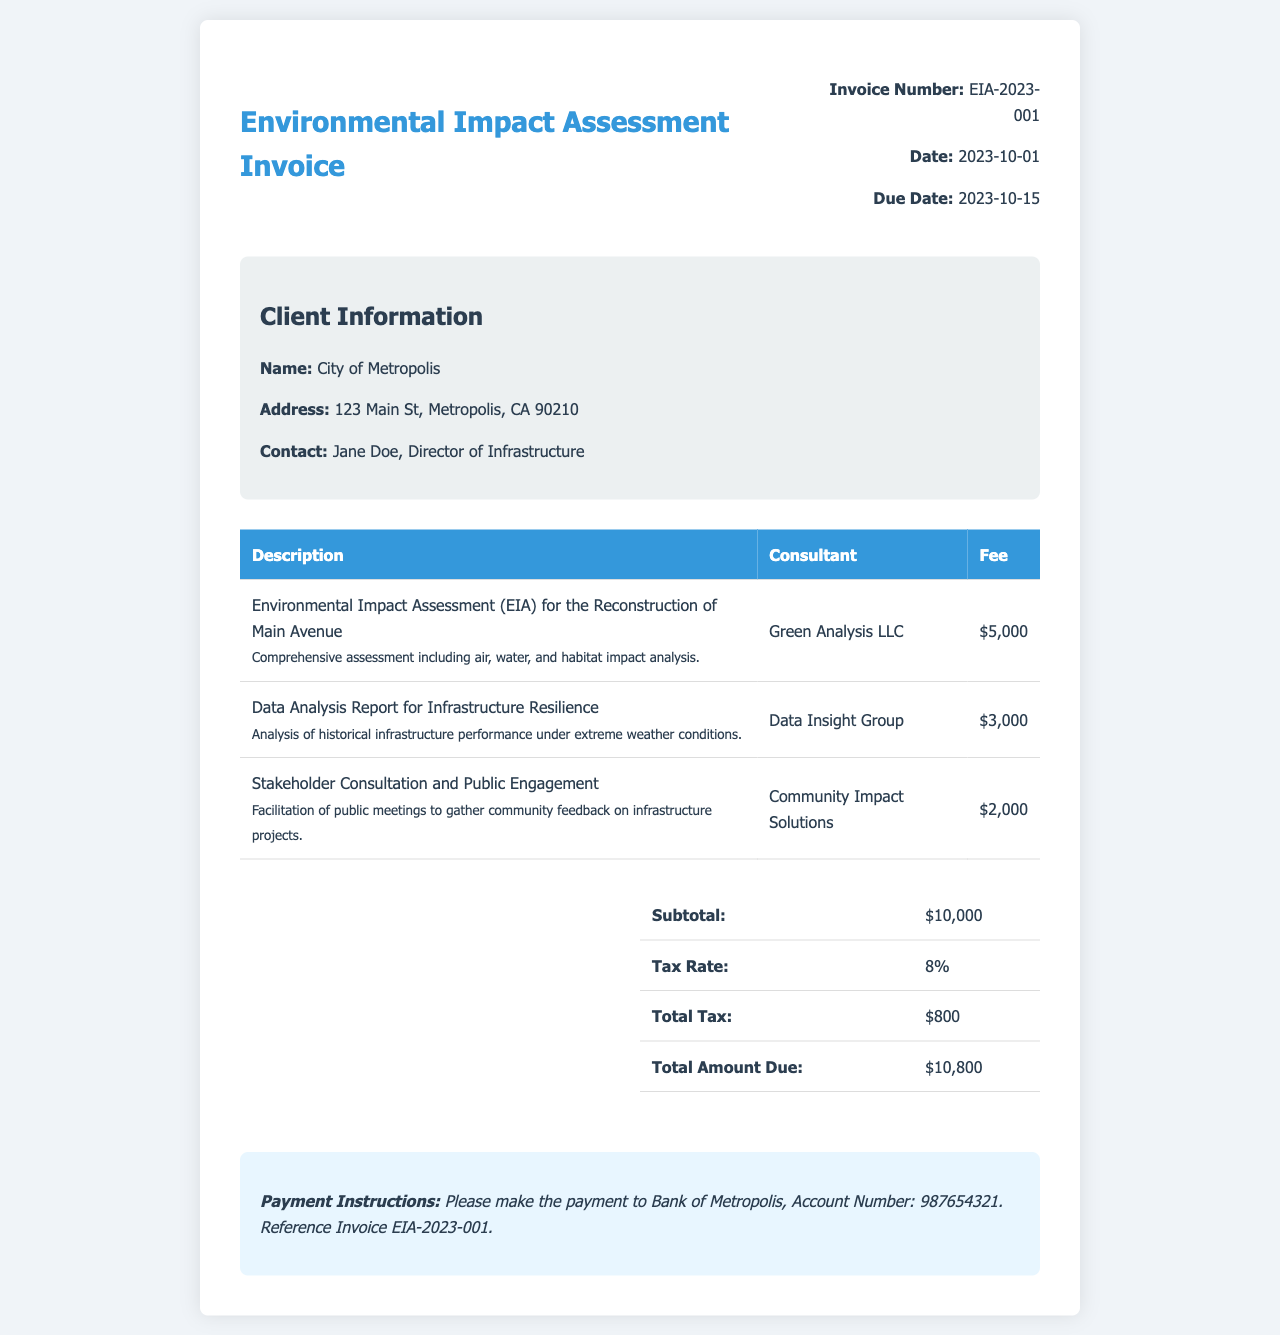What is the invoice number? The invoice number is stated clearly in the document.
Answer: EIA-2023-001 Who is the client? The document provides information about the client at the top section.
Answer: City of Metropolis What is the total amount due? The total amount due is summarized in the summary table towards the end of the document.
Answer: $10,800 What is the fee for the Environmental Impact Assessment? The document includes specific fees for each service rendered.
Answer: $5,000 What is the tax rate applied? The tax rate can be found in the summary section of the invoice.
Answer: 8% How many consultants are mentioned? The document lists three services with their respective consultants in the table.
Answer: 3 What is the due date for payment? The due date is specified in the invoice details section.
Answer: 2023-10-15 What service did Community Impact Solutions provide? The service provided by Community Impact Solutions is detailed in the services table.
Answer: Stakeholder Consultation and Public Engagement What is the subtotal before tax? The subtotal is listed in the summary table, which represents the total before tax is added.
Answer: $10,000 